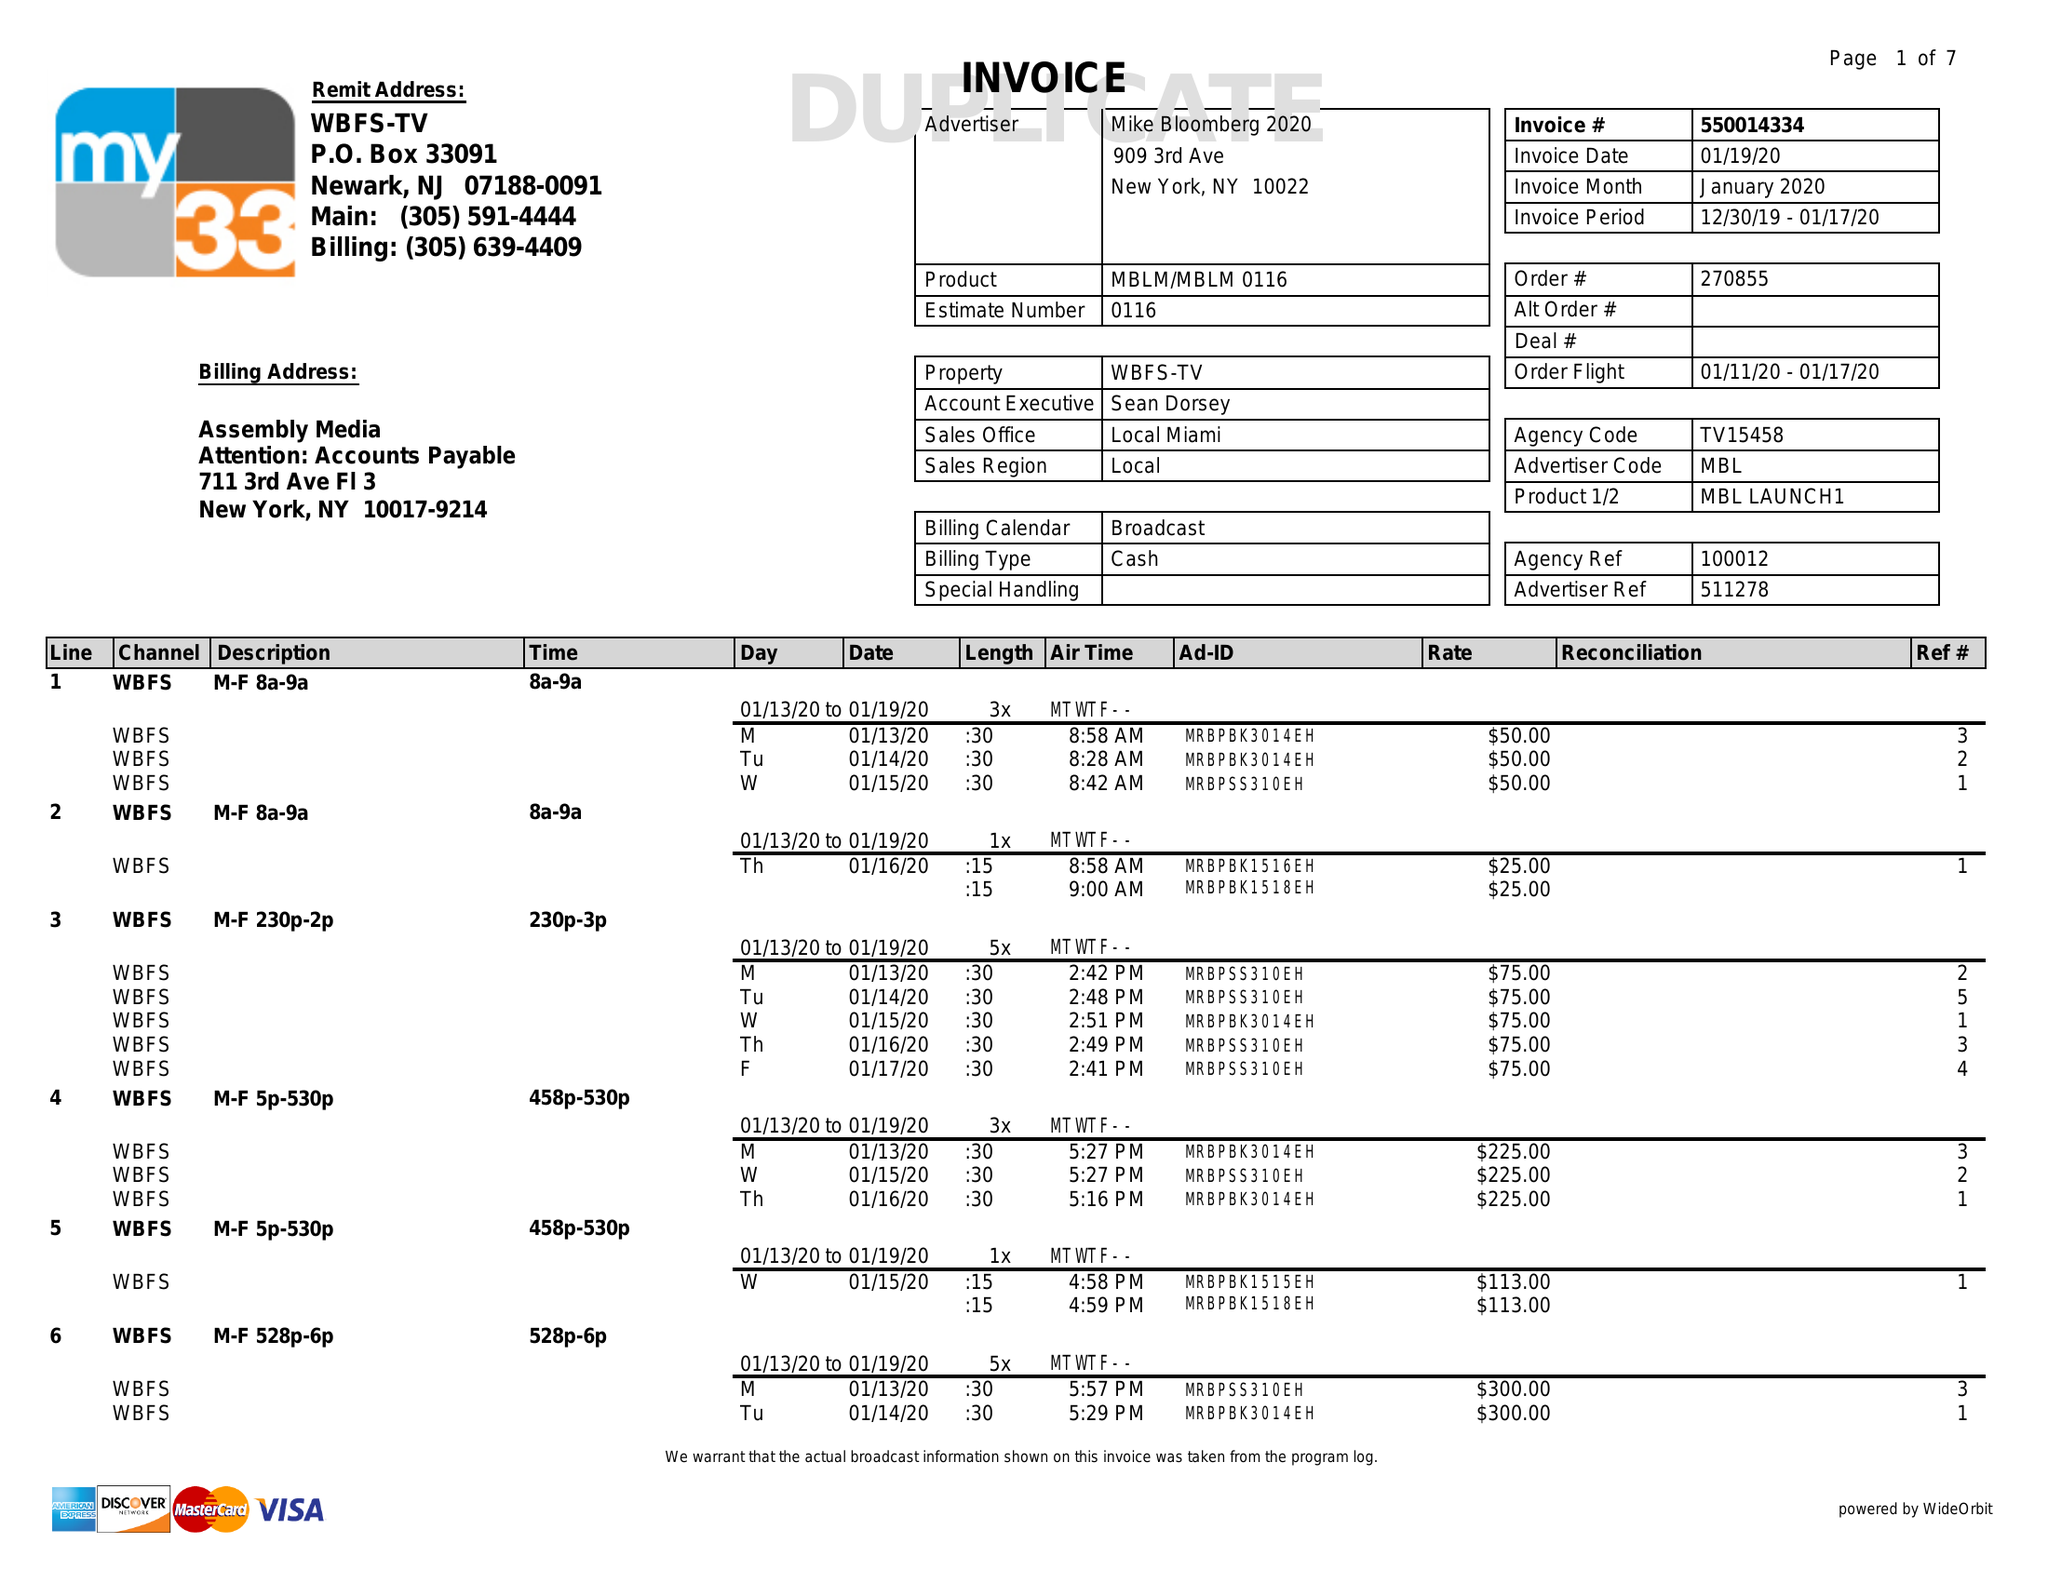What is the value for the advertiser?
Answer the question using a single word or phrase. MIKE BLOOMBERG 2020 